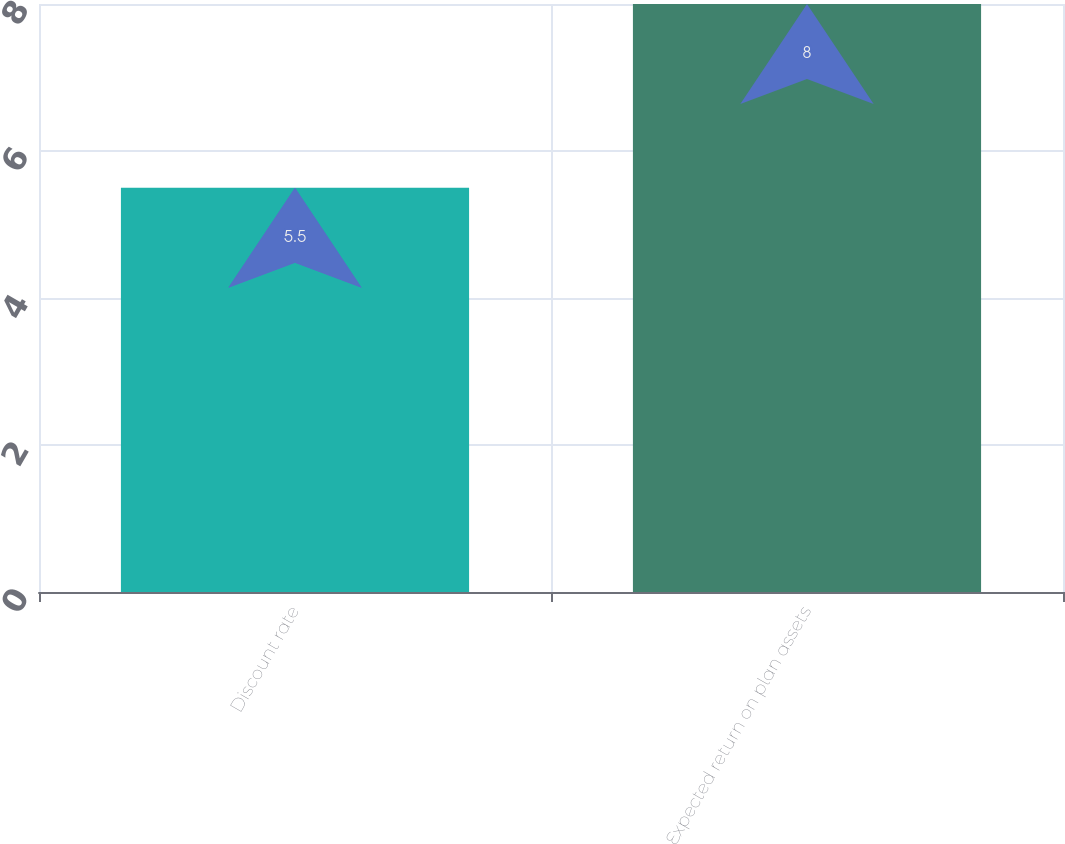Convert chart. <chart><loc_0><loc_0><loc_500><loc_500><bar_chart><fcel>Discount rate<fcel>Expected return on plan assets<nl><fcel>5.5<fcel>8<nl></chart> 